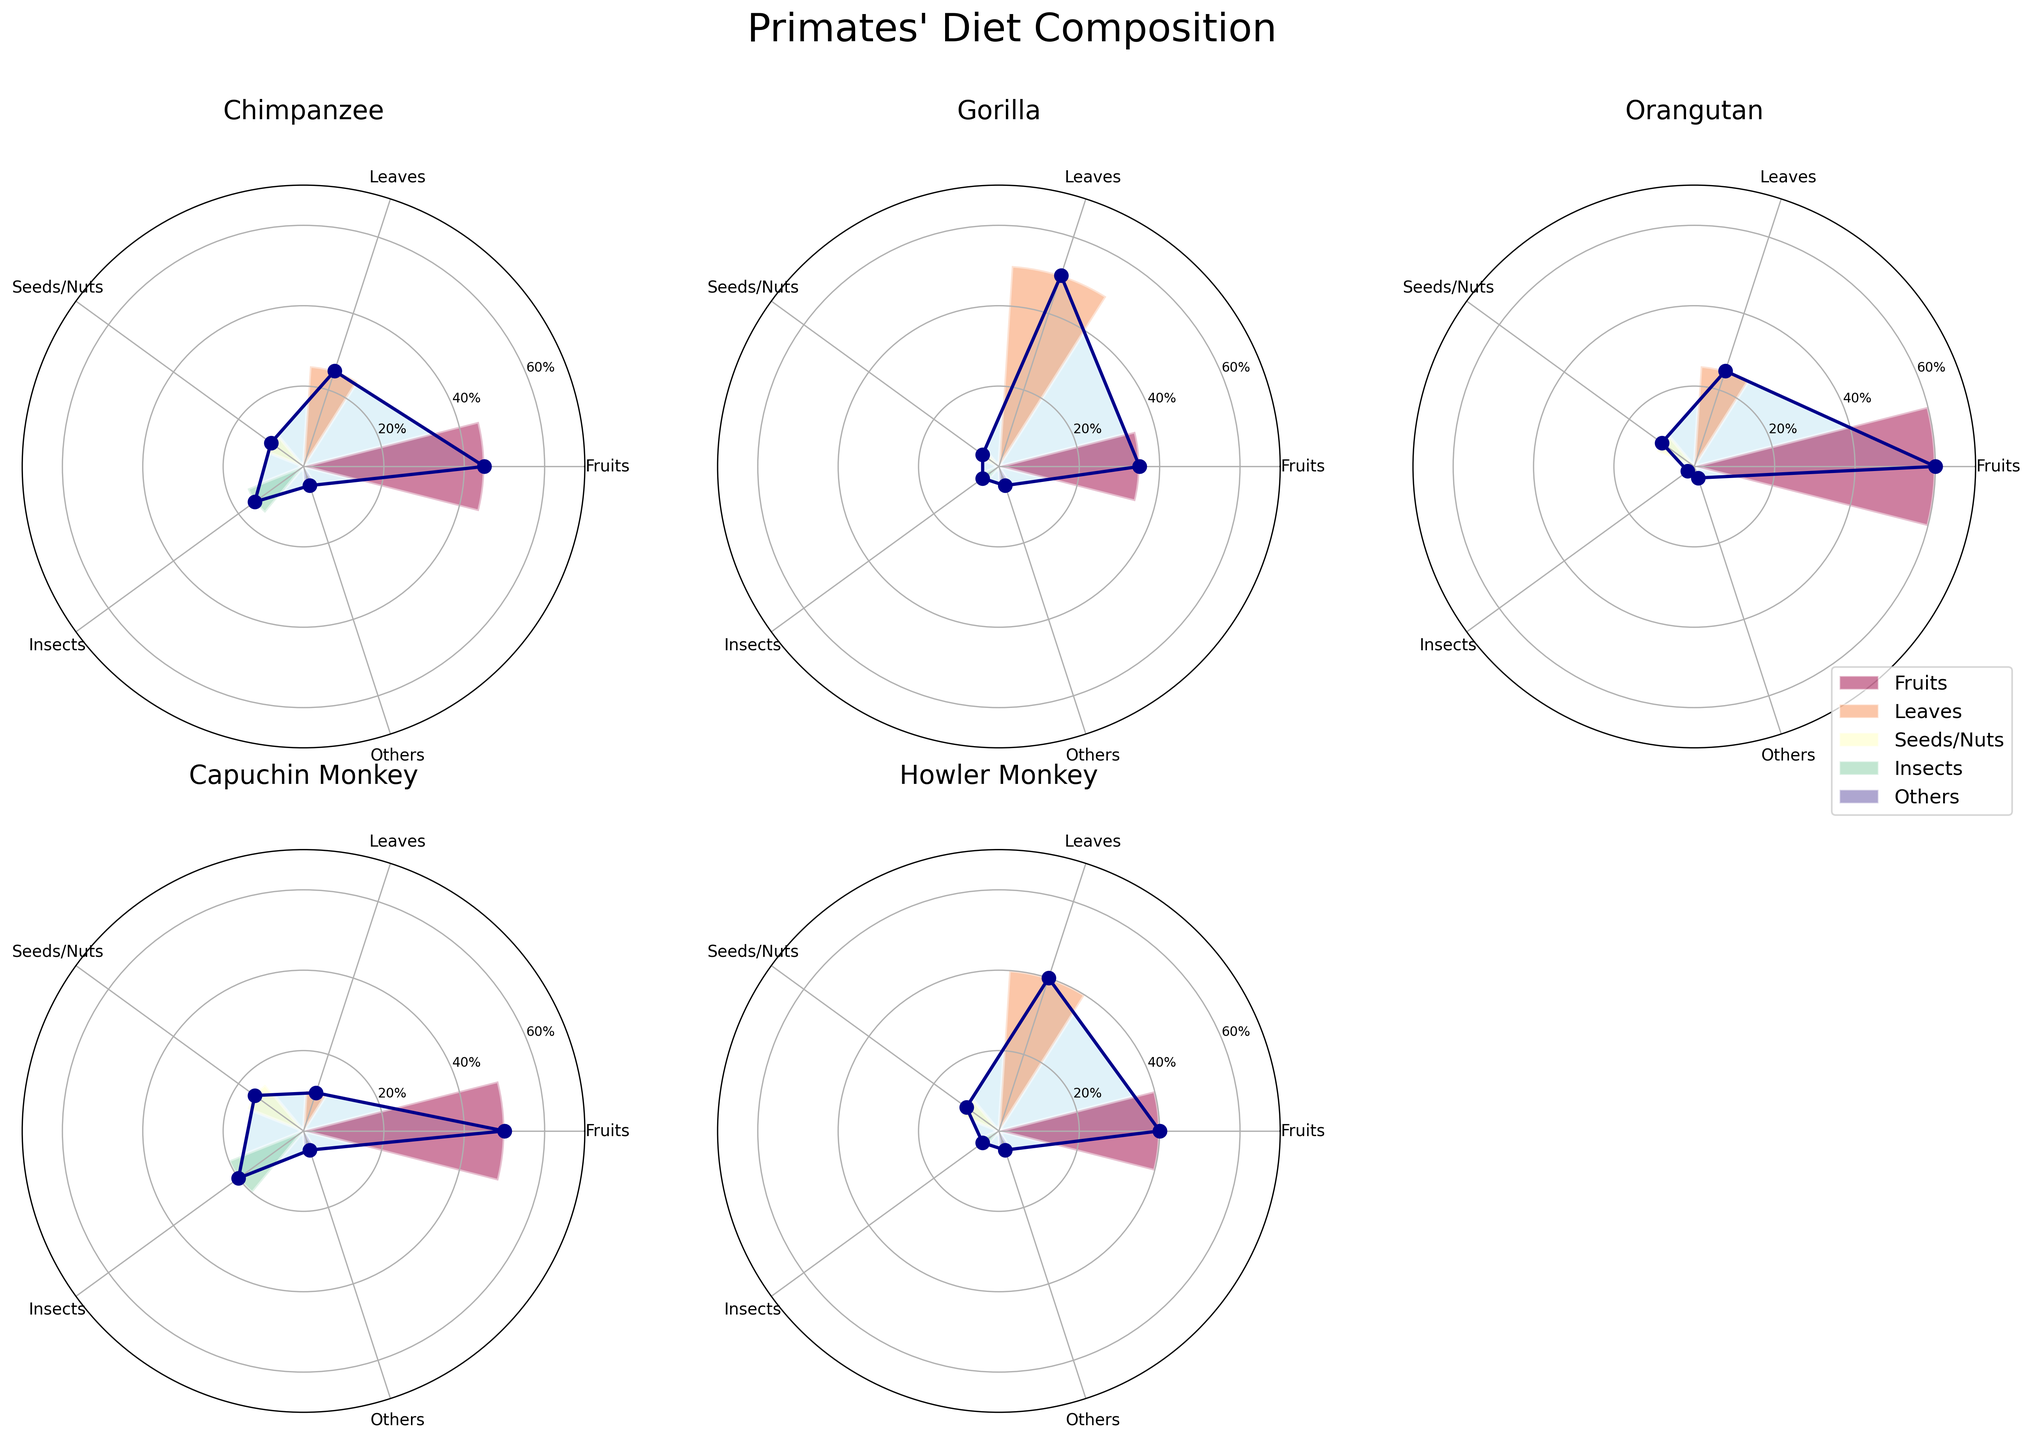Which species has the highest percentage of fruits in its diet? Find the section labeled "Fruits" in each subplot and check the percentages. Orangutans have 60%, which is the highest.
Answer: Orangutan Compare the percentage of leaves in the diets of Chimpanzees and Gorillas. Which species consumes more leaves? Locate the sections labeled "Leaves" for Chimpanzees and Gorillas. Chimpanzees have 25%, while Gorillas have 50%. Gorillas consume more leaves.
Answer: Gorillas What is the combined percentage of seeds/nuts and insects in the Capuchin Monkey's diet? Locate the sections for "Seeds/Nuts" and "Insects" in the Capuchin Monkey subplot. Add their percentages: 15% + 20%.
Answer: 35% Which diet component is least consumed by Howler Monkeys? Find and compare the percentages for each diet component in the Howler Monkey subplot. Insects and Others both have the lowest percentage at 5%.
Answer: Insects and Others How do the fruit consumption percentages of Orangutans and Chimpanzees compare? Check the "Fruits" sections for both species. Orangutans have 60%, and Chimpanzees have 45%. Orangutans consume more fruits.
Answer: Orangutans What is the average percentage of leaves consumed by the five species? Locate the "Leaves" section for each species and calculate their average: (25 + 50 + 25 + 10 + 40) / 5 = 30%.
Answer: 30% Does any species consume more than 50% of a single diet component? If so, which species and diet component? Check each section for every species to see if any percentage exceeds 50%. Orangutans consume 60% fruits, and Gorillas consume 50% leaves.
Answer: Orangutans (fruits) Which species has the most balanced diet in terms of diet composition? A balanced diet would have similar percentages across diet components. Evaluate the percentages of each species, the Howler Monkey has 40% fruits and 40% leaves, with the remaining components having lower percentages.
Answer: Howler Monkey What is the difference in insect consumption between Capuchin Monkeys and Orangutans? Check the "Insects" sections for both species. Capuchin Monkeys consume 20%, while Orangutans consume 2%. The difference is 20% - 2%.
Answer: 18% 